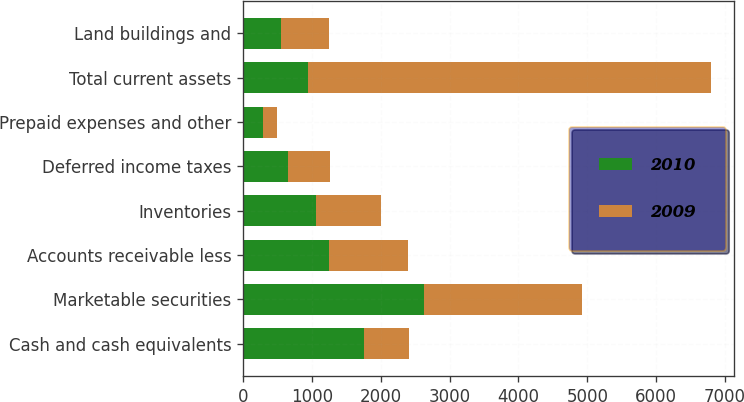<chart> <loc_0><loc_0><loc_500><loc_500><stacked_bar_chart><ecel><fcel>Cash and cash equivalents<fcel>Marketable securities<fcel>Accounts receivable less<fcel>Inventories<fcel>Deferred income taxes<fcel>Prepaid expenses and other<fcel>Total current assets<fcel>Land buildings and<nl><fcel>2010<fcel>1757.6<fcel>2622.5<fcel>1251.9<fcel>1056.8<fcel>653.2<fcel>289.4<fcel>943<fcel>553.8<nl><fcel>2009<fcel>658.7<fcel>2296.1<fcel>1147.1<fcel>943<fcel>602.2<fcel>204.1<fcel>5851.2<fcel>693.4<nl></chart> 